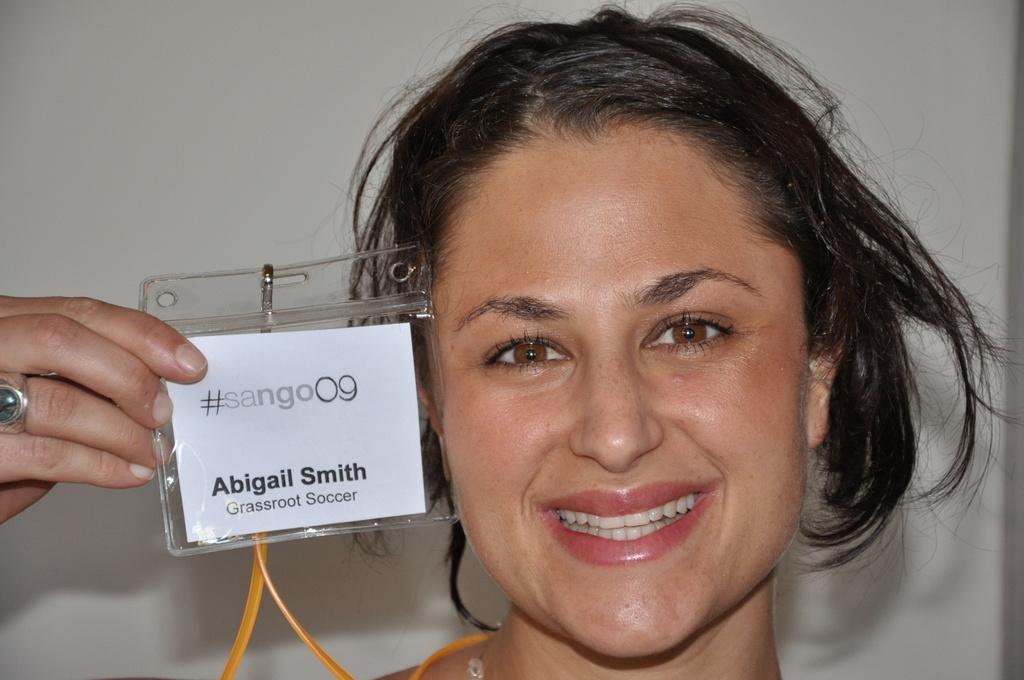Describe this image in one or two sentences. In this image, we can see a woman holding an identity card in her hand. In the background, we can see white color. 